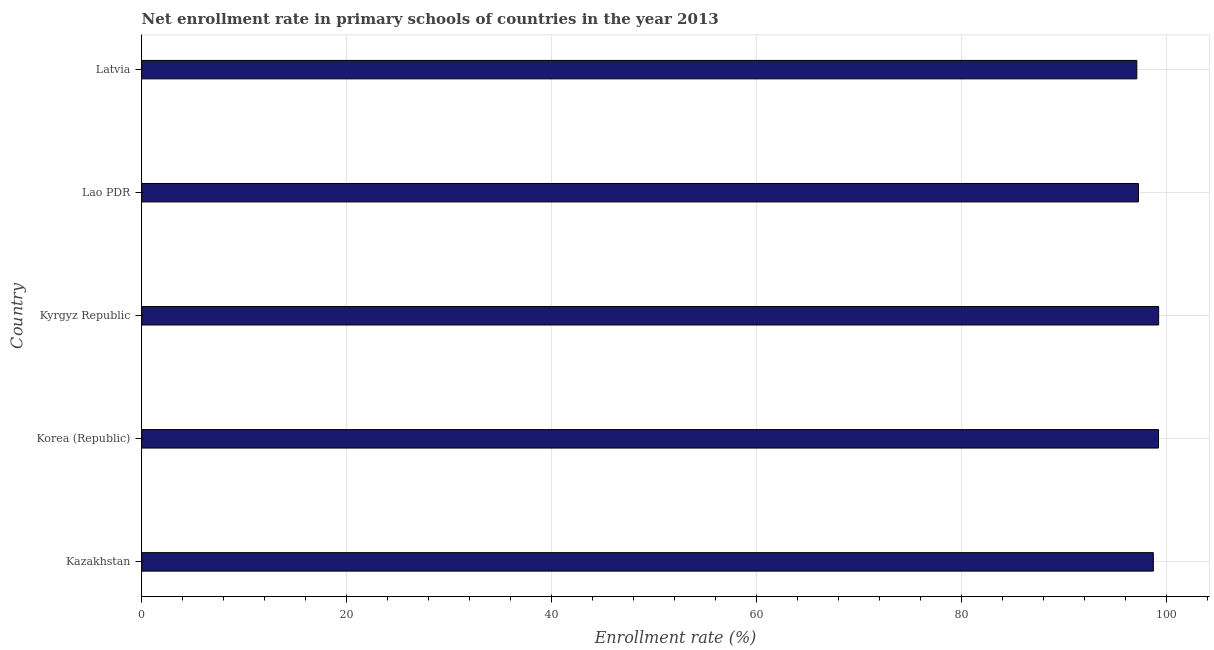Does the graph contain any zero values?
Provide a short and direct response. No. What is the title of the graph?
Make the answer very short. Net enrollment rate in primary schools of countries in the year 2013. What is the label or title of the X-axis?
Offer a terse response. Enrollment rate (%). What is the net enrollment rate in primary schools in Korea (Republic)?
Keep it short and to the point. 99.25. Across all countries, what is the maximum net enrollment rate in primary schools?
Offer a terse response. 99.26. Across all countries, what is the minimum net enrollment rate in primary schools?
Provide a succinct answer. 97.13. In which country was the net enrollment rate in primary schools maximum?
Keep it short and to the point. Kyrgyz Republic. In which country was the net enrollment rate in primary schools minimum?
Make the answer very short. Latvia. What is the sum of the net enrollment rate in primary schools?
Ensure brevity in your answer.  491.66. What is the difference between the net enrollment rate in primary schools in Korea (Republic) and Latvia?
Provide a succinct answer. 2.12. What is the average net enrollment rate in primary schools per country?
Your response must be concise. 98.33. What is the median net enrollment rate in primary schools?
Your response must be concise. 98.74. In how many countries, is the net enrollment rate in primary schools greater than 48 %?
Your answer should be very brief. 5. What is the difference between the highest and the second highest net enrollment rate in primary schools?
Ensure brevity in your answer.  0.01. Is the sum of the net enrollment rate in primary schools in Korea (Republic) and Lao PDR greater than the maximum net enrollment rate in primary schools across all countries?
Ensure brevity in your answer.  Yes. What is the difference between the highest and the lowest net enrollment rate in primary schools?
Your answer should be compact. 2.13. What is the Enrollment rate (%) of Kazakhstan?
Offer a very short reply. 98.74. What is the Enrollment rate (%) of Korea (Republic)?
Offer a terse response. 99.25. What is the Enrollment rate (%) of Kyrgyz Republic?
Keep it short and to the point. 99.26. What is the Enrollment rate (%) of Lao PDR?
Make the answer very short. 97.29. What is the Enrollment rate (%) in Latvia?
Your response must be concise. 97.13. What is the difference between the Enrollment rate (%) in Kazakhstan and Korea (Republic)?
Ensure brevity in your answer.  -0.51. What is the difference between the Enrollment rate (%) in Kazakhstan and Kyrgyz Republic?
Your answer should be very brief. -0.52. What is the difference between the Enrollment rate (%) in Kazakhstan and Lao PDR?
Provide a short and direct response. 1.45. What is the difference between the Enrollment rate (%) in Kazakhstan and Latvia?
Offer a very short reply. 1.62. What is the difference between the Enrollment rate (%) in Korea (Republic) and Kyrgyz Republic?
Offer a terse response. -0.01. What is the difference between the Enrollment rate (%) in Korea (Republic) and Lao PDR?
Your answer should be compact. 1.96. What is the difference between the Enrollment rate (%) in Korea (Republic) and Latvia?
Your answer should be very brief. 2.12. What is the difference between the Enrollment rate (%) in Kyrgyz Republic and Lao PDR?
Offer a terse response. 1.97. What is the difference between the Enrollment rate (%) in Kyrgyz Republic and Latvia?
Provide a succinct answer. 2.13. What is the difference between the Enrollment rate (%) in Lao PDR and Latvia?
Your response must be concise. 0.16. What is the ratio of the Enrollment rate (%) in Kazakhstan to that in Korea (Republic)?
Keep it short and to the point. 0.99. What is the ratio of the Enrollment rate (%) in Kazakhstan to that in Latvia?
Offer a very short reply. 1.02. What is the ratio of the Enrollment rate (%) in Korea (Republic) to that in Kyrgyz Republic?
Make the answer very short. 1. What is the ratio of the Enrollment rate (%) in Korea (Republic) to that in Latvia?
Provide a short and direct response. 1.02. 